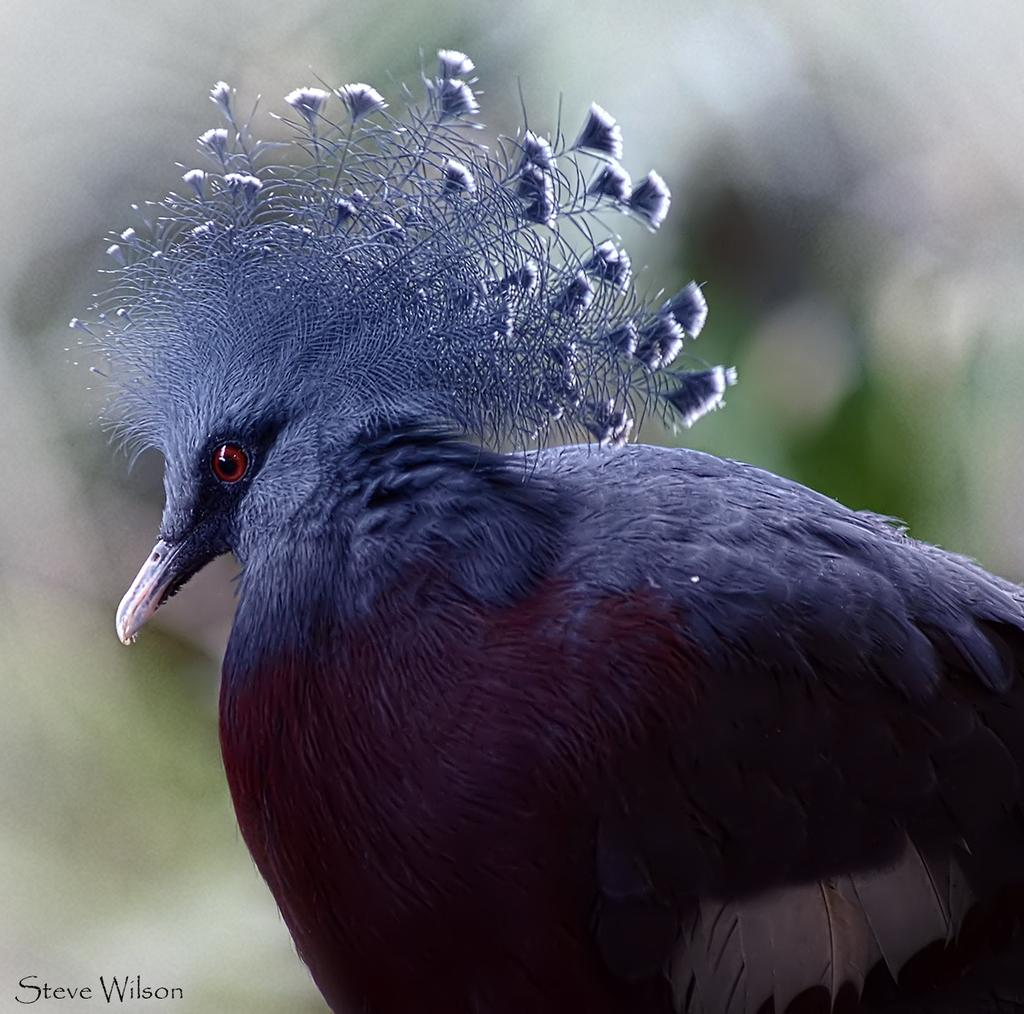What type of animal is present in the image? There is a bird in the image. Can you describe any additional features or elements in the image? Yes, there is a watermark at the left bottom of the image. What type of finger can be seen holding the bird in the image? There is no finger present in the image, nor is there any indication that the bird is being held. What type of mint is visible in the image? There is no mint present in the image. 